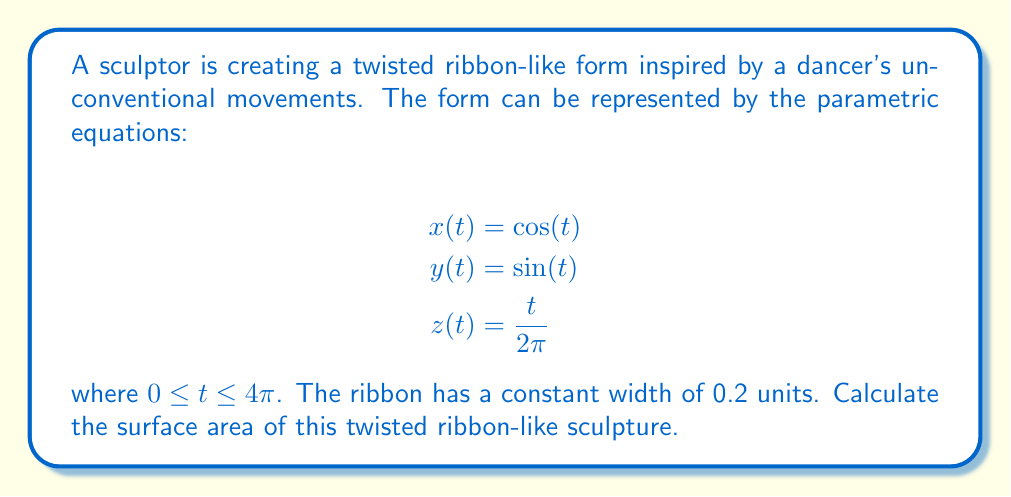Show me your answer to this math problem. To find the surface area of this twisted ribbon-like form, we need to use the surface area formula for a parametric surface:

$$A = \int_a^b \int_0^w \sqrt{EG - F^2} \, du \, dt$$

where $E$, $F$, and $G$ are the coefficients of the first fundamental form, $w$ is the width of the ribbon, and $[a,b]$ is the interval for $t$.

1) First, we need to find the tangent vector $\mathbf{r}'(t)$:

   $$\mathbf{r}'(t) = (-\sin(t), \cos(t), \frac{1}{2\pi})$$

2) Next, we need to find a unit normal vector to the curve. We can use the Frenet frame:

   $$\mathbf{T}(t) = \frac{\mathbf{r}'(t)}{|\mathbf{r}'(t)|} = \frac{(-\sin(t), \cos(t), \frac{1}{2\pi})}{\sqrt{\sin^2(t) + \cos^2(t) + (\frac{1}{2\pi})^2}}$$

   $$\mathbf{N}(t) = \frac{\mathbf{T}'(t)}{|\mathbf{T}'(t)|} = (-\cos(t), -\sin(t), 0)$$

   $$\mathbf{B}(t) = \mathbf{T}(t) \times \mathbf{N}(t) = (\frac{\sin(t)}{2\pi}, -\frac{\cos(t)}{2\pi}, 1)$$

3) The surface can be parameterized as:

   $$\mathbf{S}(t,u) = \mathbf{r}(t) + u\mathbf{B}(t)$$

   where $-0.1 \leq u \leq 0.1$ (half the width on each side of the curve)

4) Now we can compute $E$, $F$, and $G$:

   $$E = |\mathbf{S}_t|^2 = 1 + \frac{1}{4\pi^2}$$
   $$F = \mathbf{S}_t \cdot \mathbf{S}_u = 0$$
   $$G = |\mathbf{S}_u|^2 = 1$$

5) Therefore, $EG - F^2 = 1 + \frac{1}{4\pi^2}$

6) The surface area is:

   $$A = \int_0^{4\pi} \int_{-0.1}^{0.1} \sqrt{1 + \frac{1}{4\pi^2}} \, du \, dt$$

7) Evaluating the integral:

   $$A = 4\pi \cdot 0.2 \cdot \sqrt{1 + \frac{1}{4\pi^2}} = 0.8\pi \sqrt{1 + \frac{1}{4\pi^2}}$$
Answer: The surface area of the twisted ribbon-like sculpture is $0.8\pi \sqrt{1 + \frac{1}{4\pi^2}} \approx 2.513$ square units. 